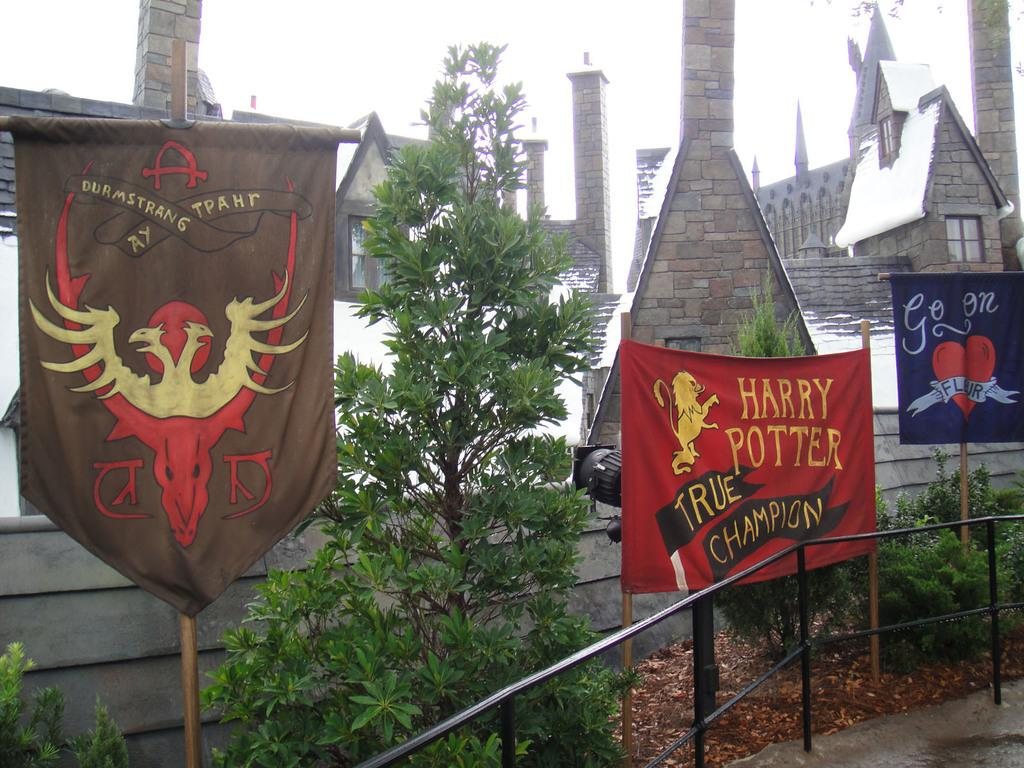Provide a one-sentence caption for the provided image. A banner for Harry Potter can be seen outside of a Hogwarts theme park. 